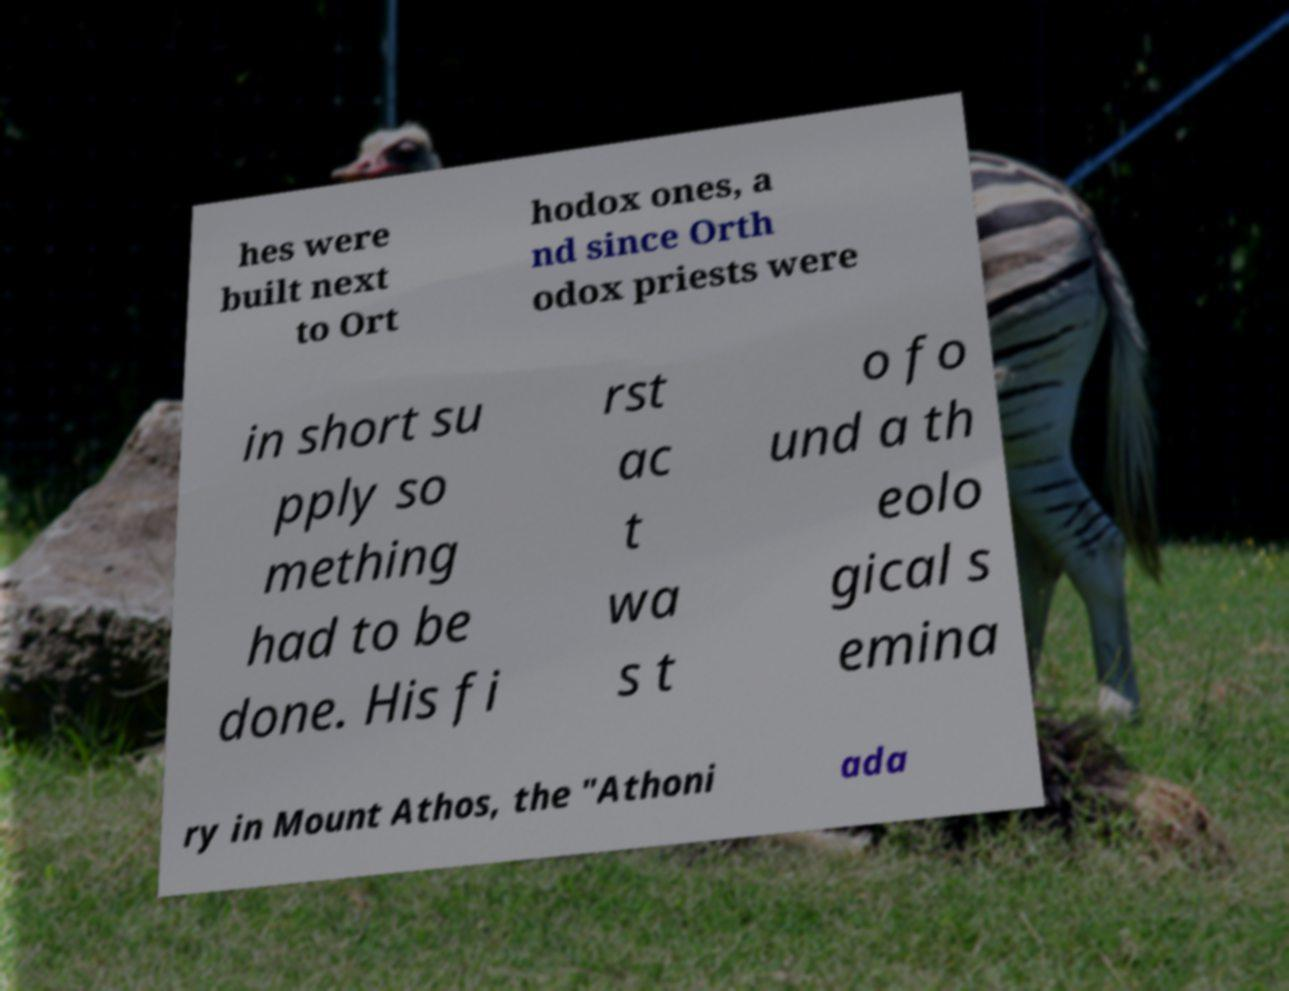For documentation purposes, I need the text within this image transcribed. Could you provide that? hes were built next to Ort hodox ones, a nd since Orth odox priests were in short su pply so mething had to be done. His fi rst ac t wa s t o fo und a th eolo gical s emina ry in Mount Athos, the "Athoni ada 